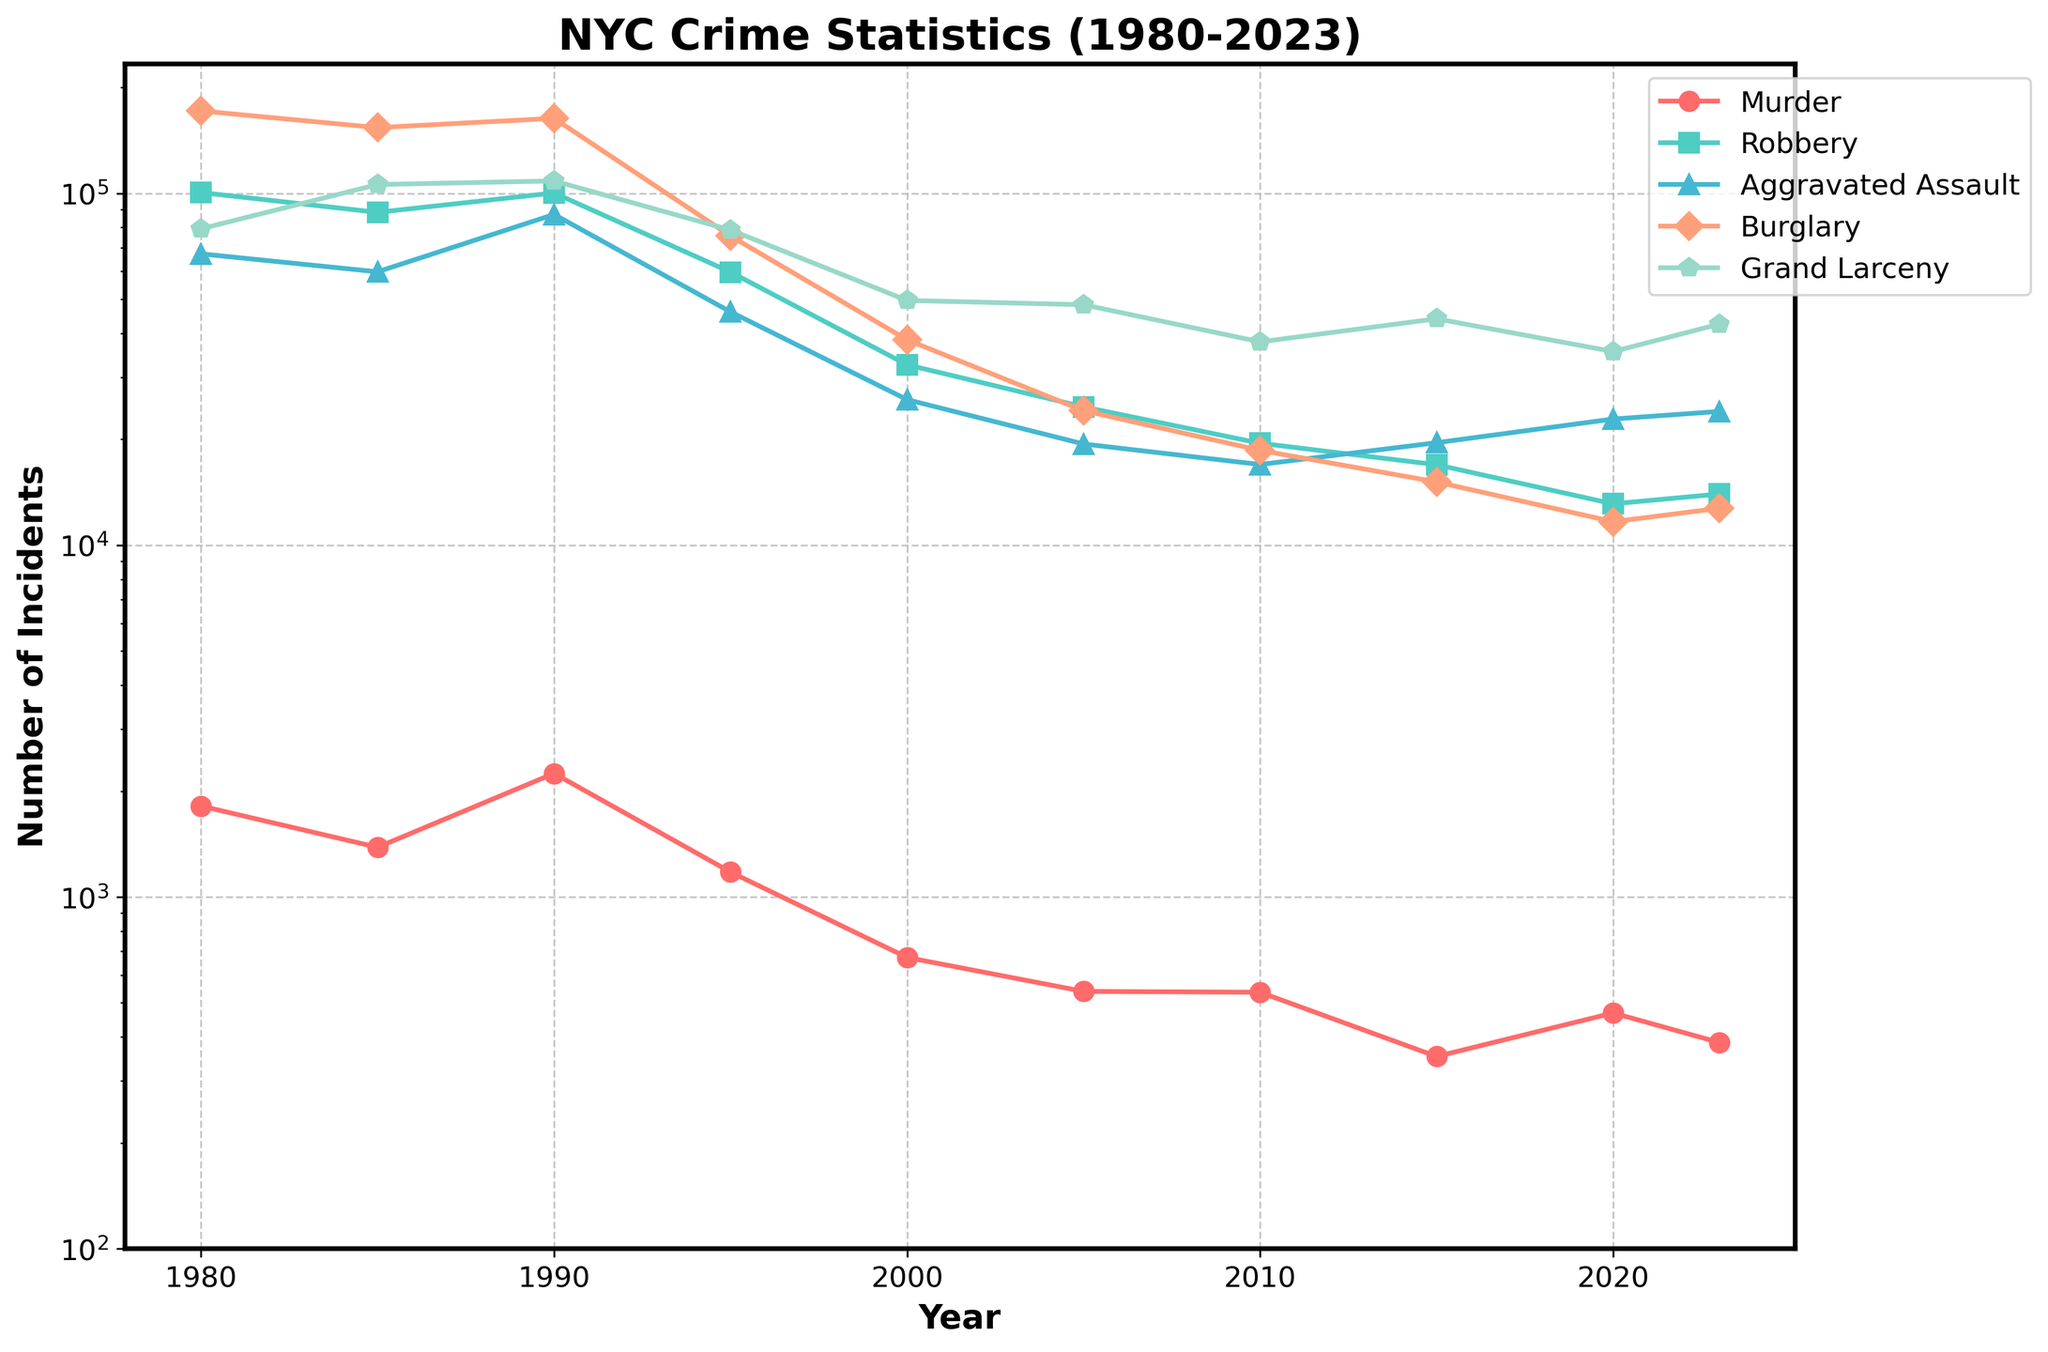How has the murder rate changed between 1980 and 2023? To find the change in the murder rate, compare the values in 1980 and 2023. In 1980, the murder rate was 1814, and in 2023, it was 386. Subtract the latter from the former to find the change.
Answer: The murder rate has decreased by 1428 Which year saw the highest number of burglaries? Look at the plot and identify the peak point for burglary incidents over the years. The highest point will indicate the year with the most burglaries.
Answer: 1980 In which year did the number of grand larceny incidents first drop below 50,000? Trace the grand larceny line on the chart and locate the year when the number of incidents goes below the 50,000 mark for the first time.
Answer: 1995 By how much did the robbery rate decrease from 1990 to 2000? Find the robbery rates for 1990 and 2000 from the plot, which are 100280 and 32562, respectively. Subtract the 2000 value from the 1990 value to calculate the decrease.
Answer: The robbery rate decreased by 67718 Which offense type had the smallest reduction in incidents from 1980 to 2023? Compare the reductions for each offense type by subtracting the 2023 value from the 1980 value for each offense. The smallest difference indicates the smallest reduction.
Answer: Aggravated Assault What is the average number of murder incidents per year from 1980 to 2023? To find the average, add up all the yearly murder incidents and divide by the number of years (factoring in the ten data points for each year). The sum of murder incidents is 8389. Divide this by 10.
Answer: The average number of murder incidents per year is 838.9 Which offense had the most consistent decline in incidents over the entire period? Observe the trends for each offense type and identify which one has a consistent downward trajectory without significant fluctuations.
Answer: Burglary By what percentage did aggravated assault incidents increase from 2000 to 2023? Calculate the percentage increase by using the formula: ((value in 2023 - value in 2000) / value in 2000) * 100. The values are 23990 (2023) and 25924 (2000).
Answer: 92.6% Which offense type had the steepest decline in the 1990s? Analyze the trends for each offense type from 1990 to 2000 and determine which one had the greatest drop in incidents.
Answer: Robbery Is there any offense type that increased in incidents from 2005 to 2023? If so, which one? Compare the values for each offense type from 2005 and 2023 to see if any have increased. Identify the one with an increase.
Answer: Grand Larceny 